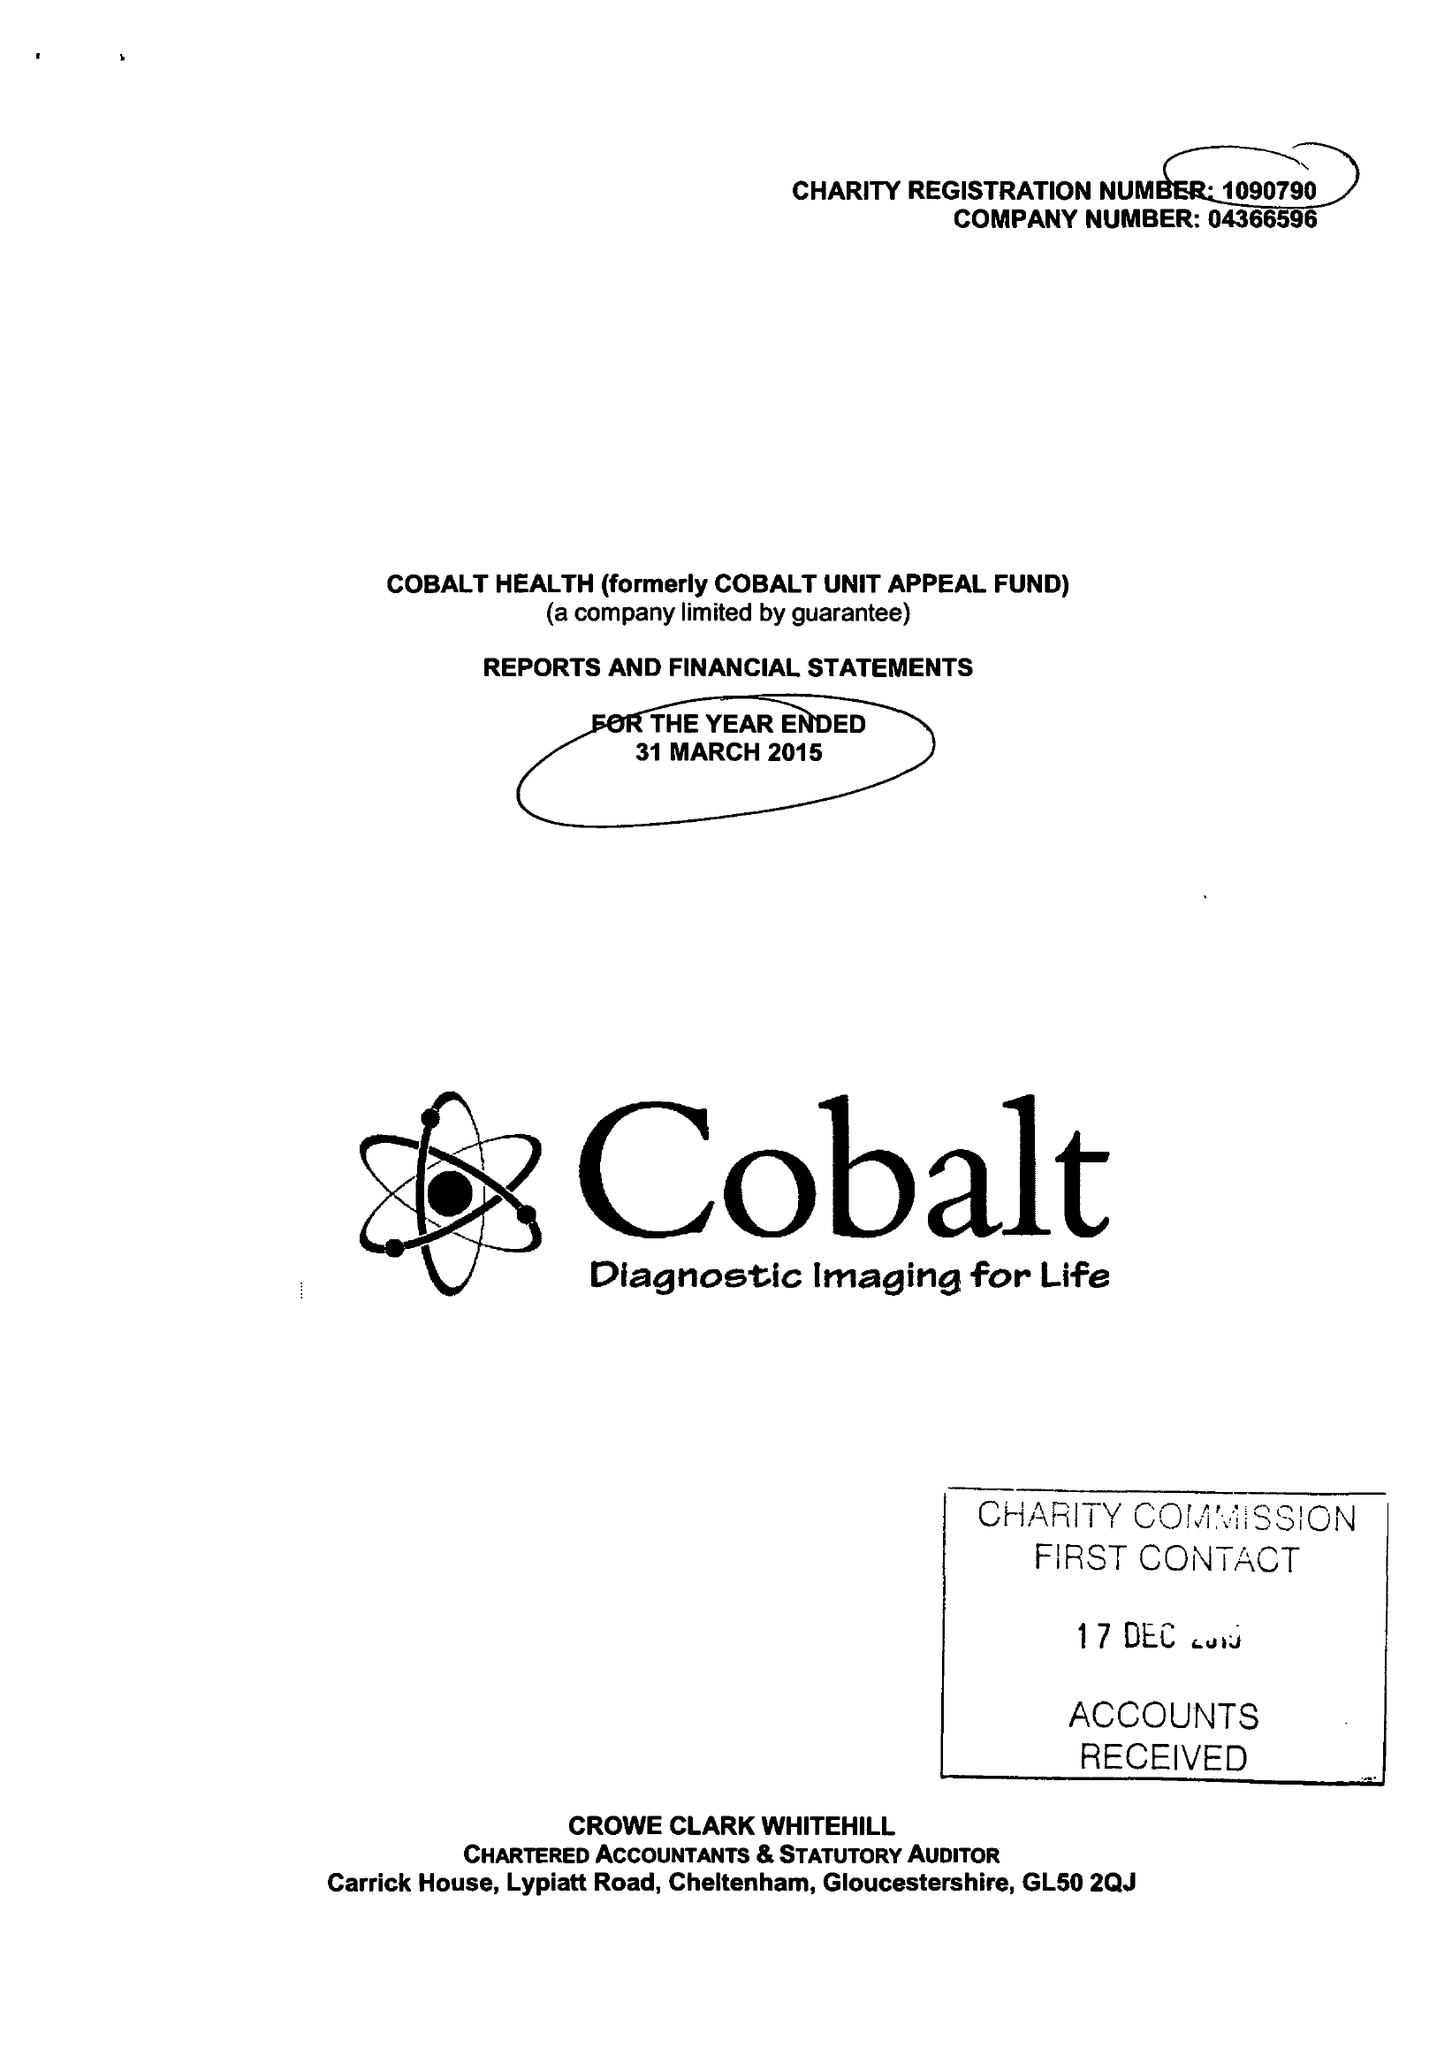What is the value for the address__postcode?
Answer the question using a single word or phrase. GL53 7AS 